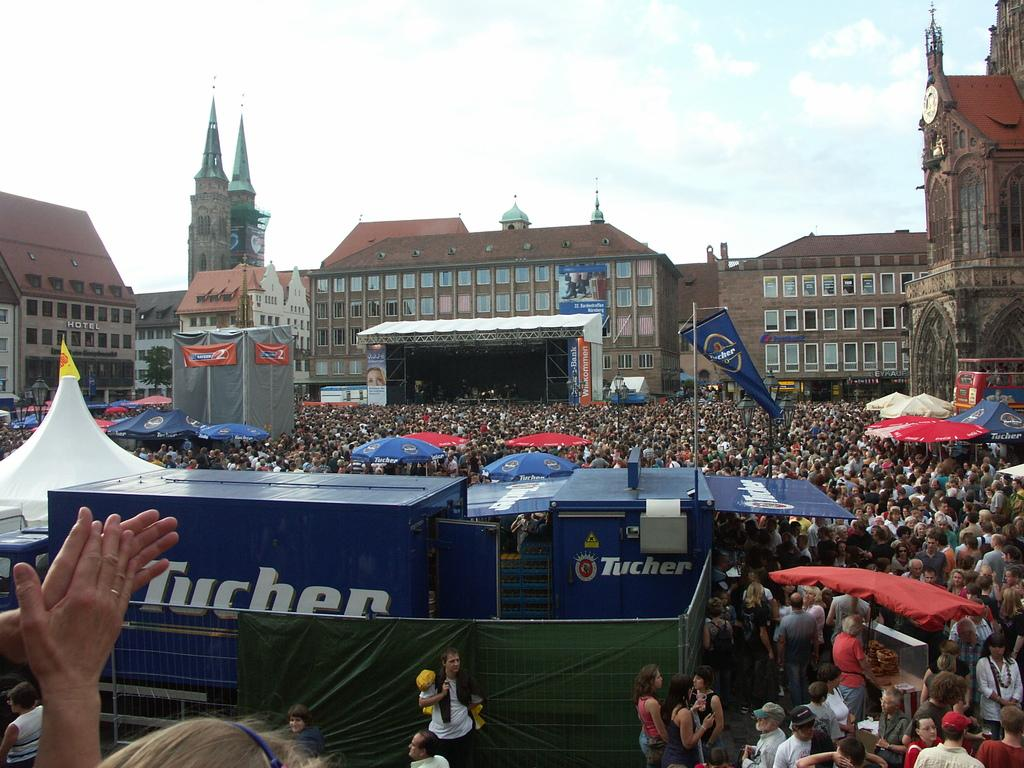What type of structures are visible in the image? There are buildings with windows in the image. What else can be seen in the image besides the buildings? There is a crowd in the image, as well as a banner and umbrellas. What type of cork apparatus can be seen in the image? There is no cork apparatus present in the image. What type of amusement can be seen in the image? The image does not depict any specific amusement; it features buildings, a crowd, a banner, and umbrellas. 